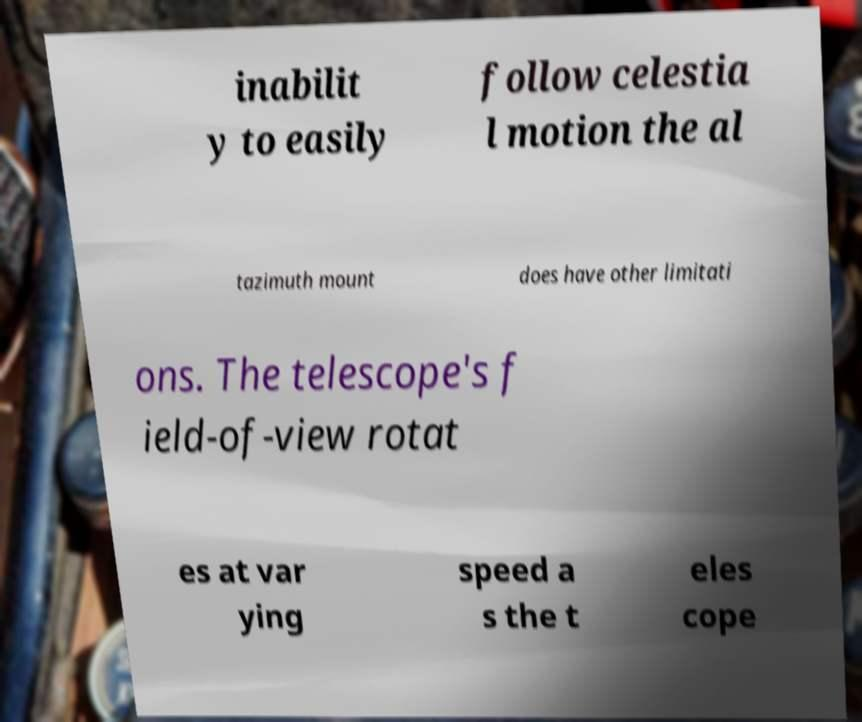Could you assist in decoding the text presented in this image and type it out clearly? inabilit y to easily follow celestia l motion the al tazimuth mount does have other limitati ons. The telescope's f ield-of-view rotat es at var ying speed a s the t eles cope 